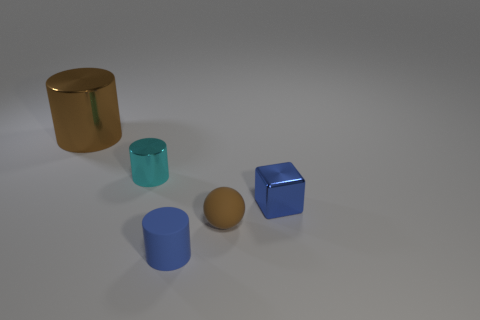Subtract all small cylinders. How many cylinders are left? 1 Add 1 big objects. How many objects exist? 6 Subtract all gray cylinders. Subtract all gray spheres. How many cylinders are left? 3 Subtract all blocks. How many objects are left? 4 Add 3 matte cylinders. How many matte cylinders are left? 4 Add 2 small red matte blocks. How many small red matte blocks exist? 2 Subtract 0 yellow cubes. How many objects are left? 5 Subtract all green metal blocks. Subtract all tiny rubber objects. How many objects are left? 3 